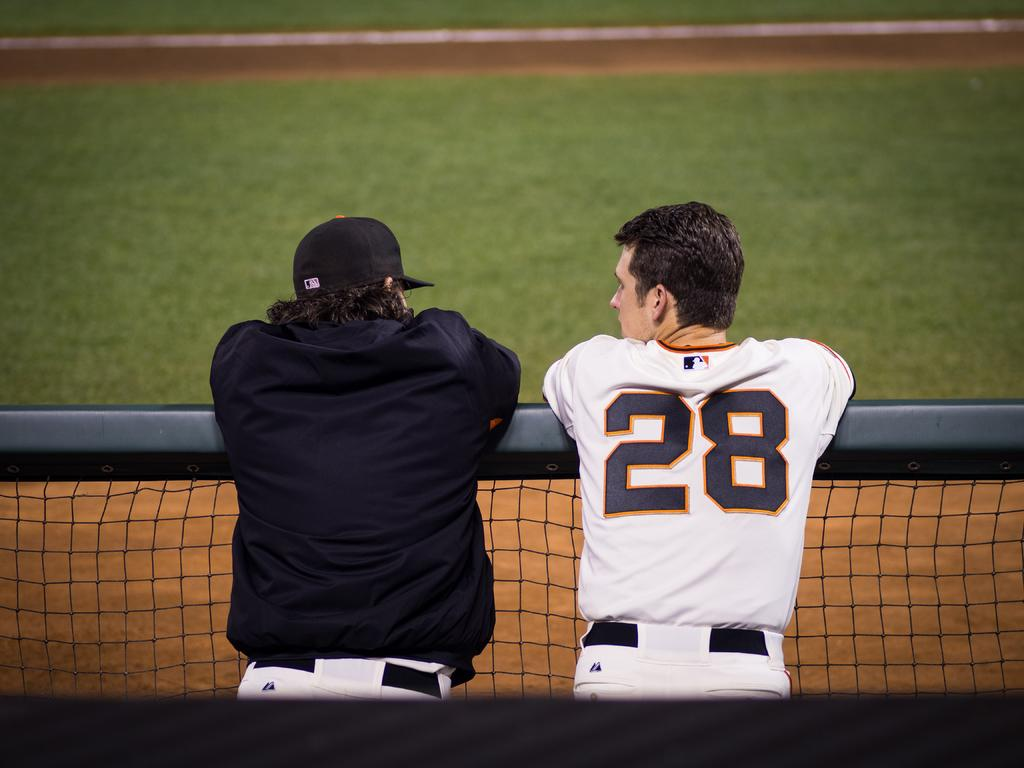<image>
Present a compact description of the photo's key features. A baseball player no. 28 is leaning over the railing next to another player wearing a black jacket. 